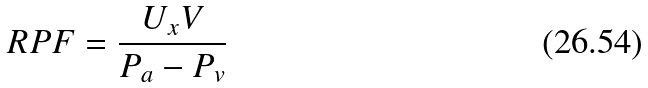<formula> <loc_0><loc_0><loc_500><loc_500>R P F = \frac { U _ { x } V } { P _ { a } - P _ { v } }</formula> 